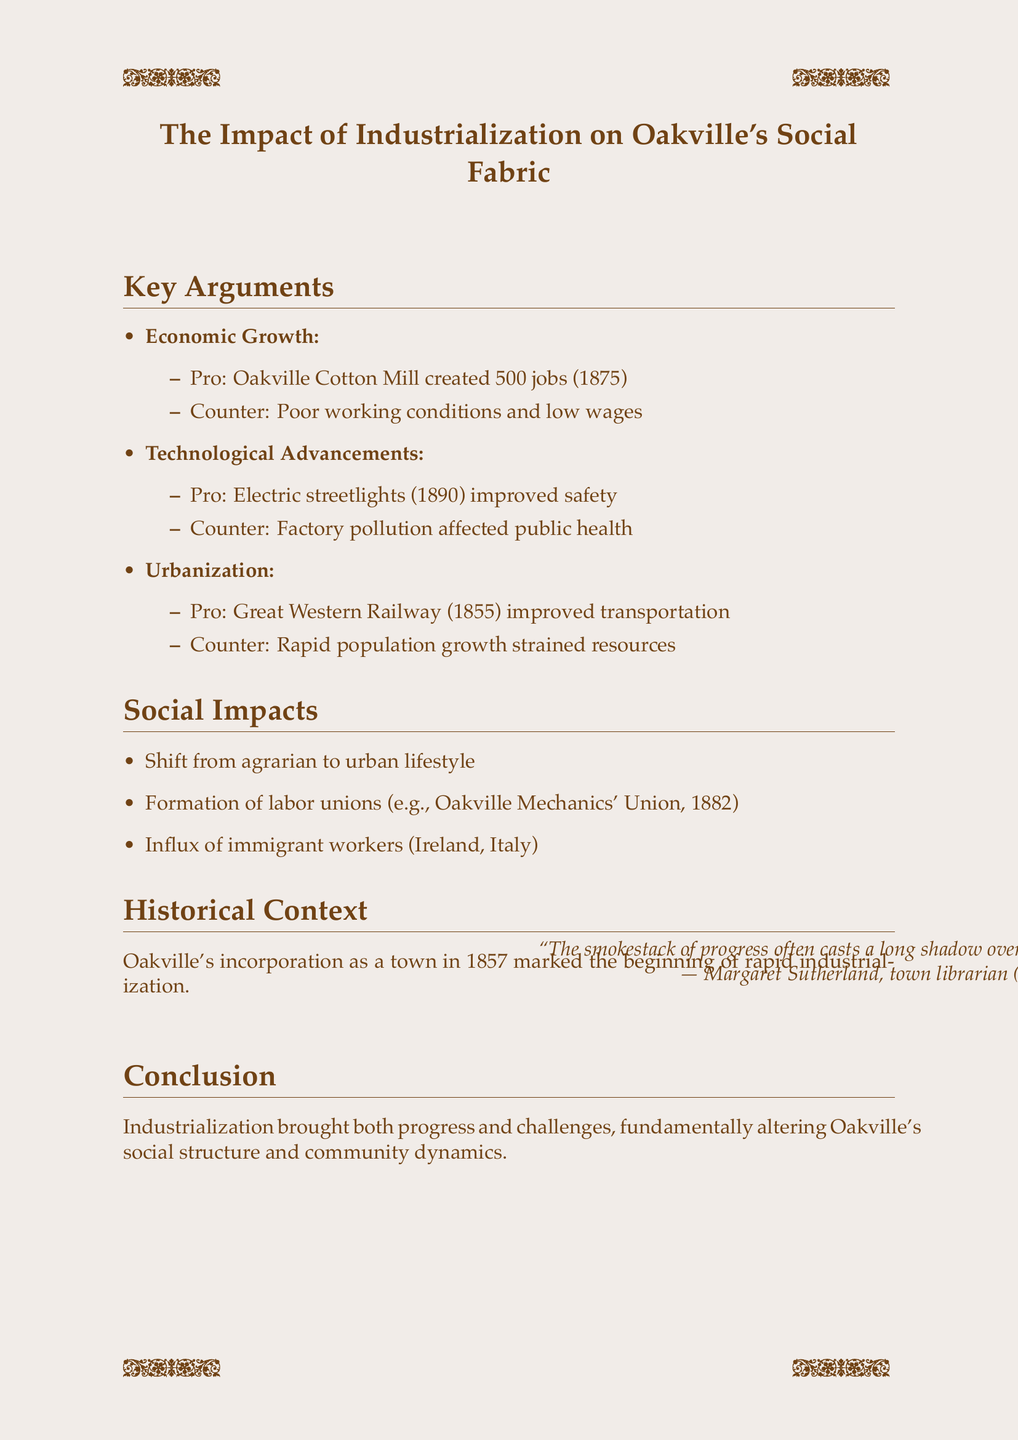What was the title of the debate? The title of the debate is stated at the beginning of the document, which is "The Impact of Industrialization on Oakville's Social Fabric."
Answer: The Impact of Industrialization on Oakville's Social Fabric What year did the Oakville Cotton Mill create new jobs? The document mentions that the Oakville Cotton Mill brought new jobs in the year 1875.
Answer: 1875 Which technological advancement improved safety in 1890? The document specifies that electric streetlights introduced in 1890 improved safety.
Answer: Electric streetlights What social group was formed in 1882? The document indicates that the Oakville Mechanics' Union was formed in 1882.
Answer: Oakville Mechanics' Union What significant event occurred in Oakville in 1857? The document states that 1857 is the year Oakville was incorporated as a town, marking the beginning of rapid industrialization.
Answer: Incorporation of Oakville as a town Why did rapid population growth lead to challenges? The document informs that rapid population growth strained existing resources.
Answer: Strained existing resources Who attributed the quote about the smokestack of progress? The quote in the document is attributed to Margaret Sutherland, who was a town librarian from 1870 to 1905.
Answer: Margaret Sutherland What was a major impact of industrialization on the town's lifestyle? The document mentions that there was a shift from an agrarian to an urban lifestyle due to industrialization.
Answer: Shift from agrarian to urban lifestyle What is the conclusion drawn about industrialization's impact on Oakville? The document concludes that industrialization brought both progress and challenges, fundamentally altering Oakville's social structure and community dynamics.
Answer: Both progress and challenges 